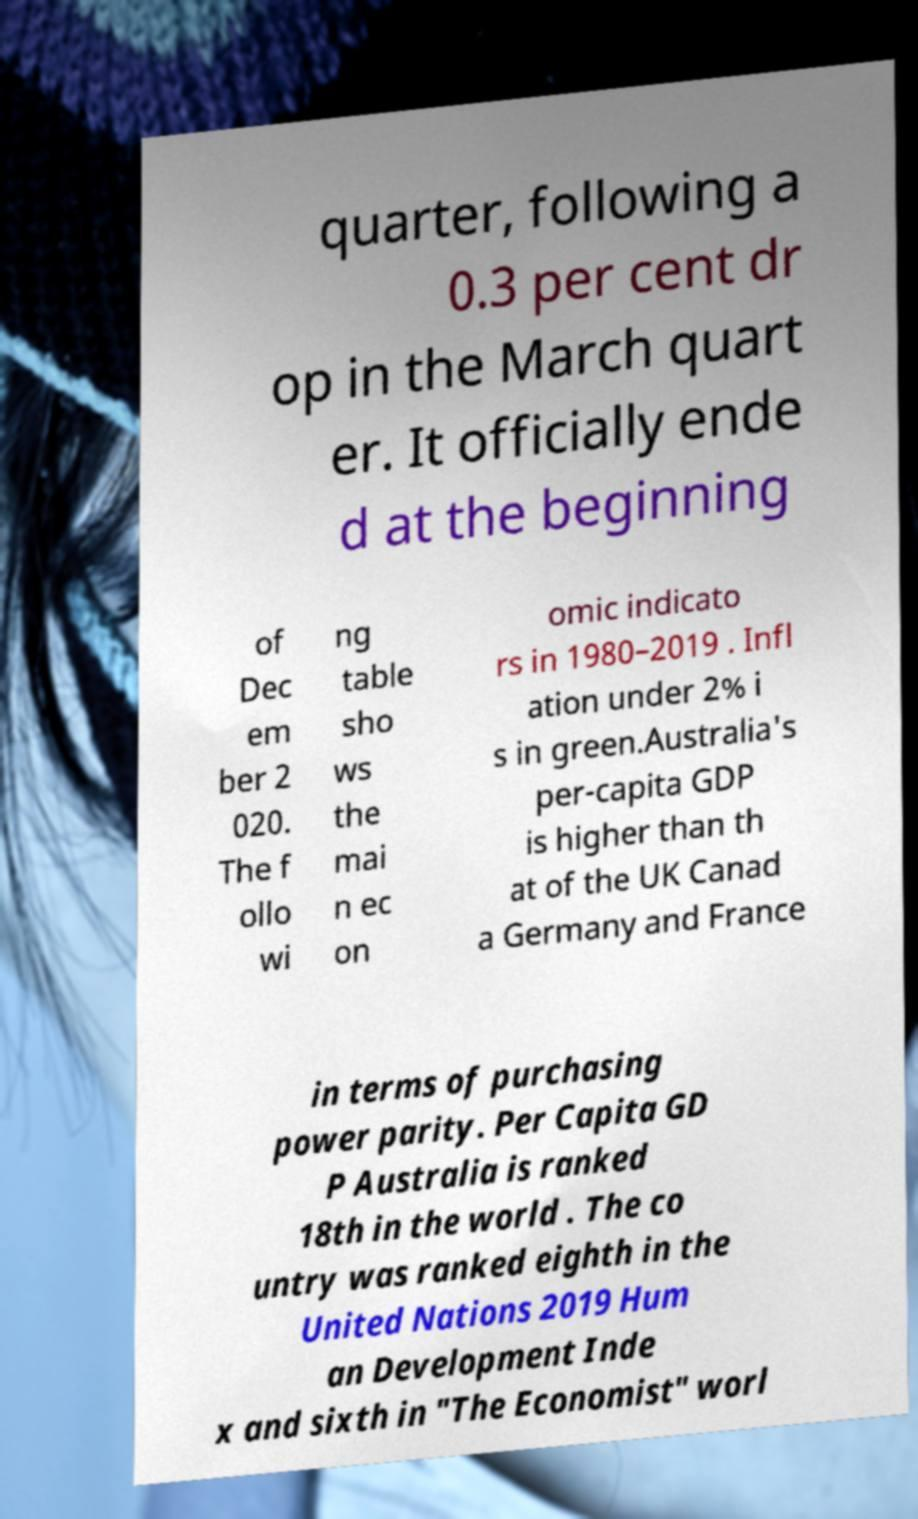Please identify and transcribe the text found in this image. quarter, following a 0.3 per cent dr op in the March quart er. It officially ende d at the beginning of Dec em ber 2 020. The f ollo wi ng table sho ws the mai n ec on omic indicato rs in 1980–2019 . Infl ation under 2% i s in green.Australia's per-capita GDP is higher than th at of the UK Canad a Germany and France in terms of purchasing power parity. Per Capita GD P Australia is ranked 18th in the world . The co untry was ranked eighth in the United Nations 2019 Hum an Development Inde x and sixth in "The Economist" worl 